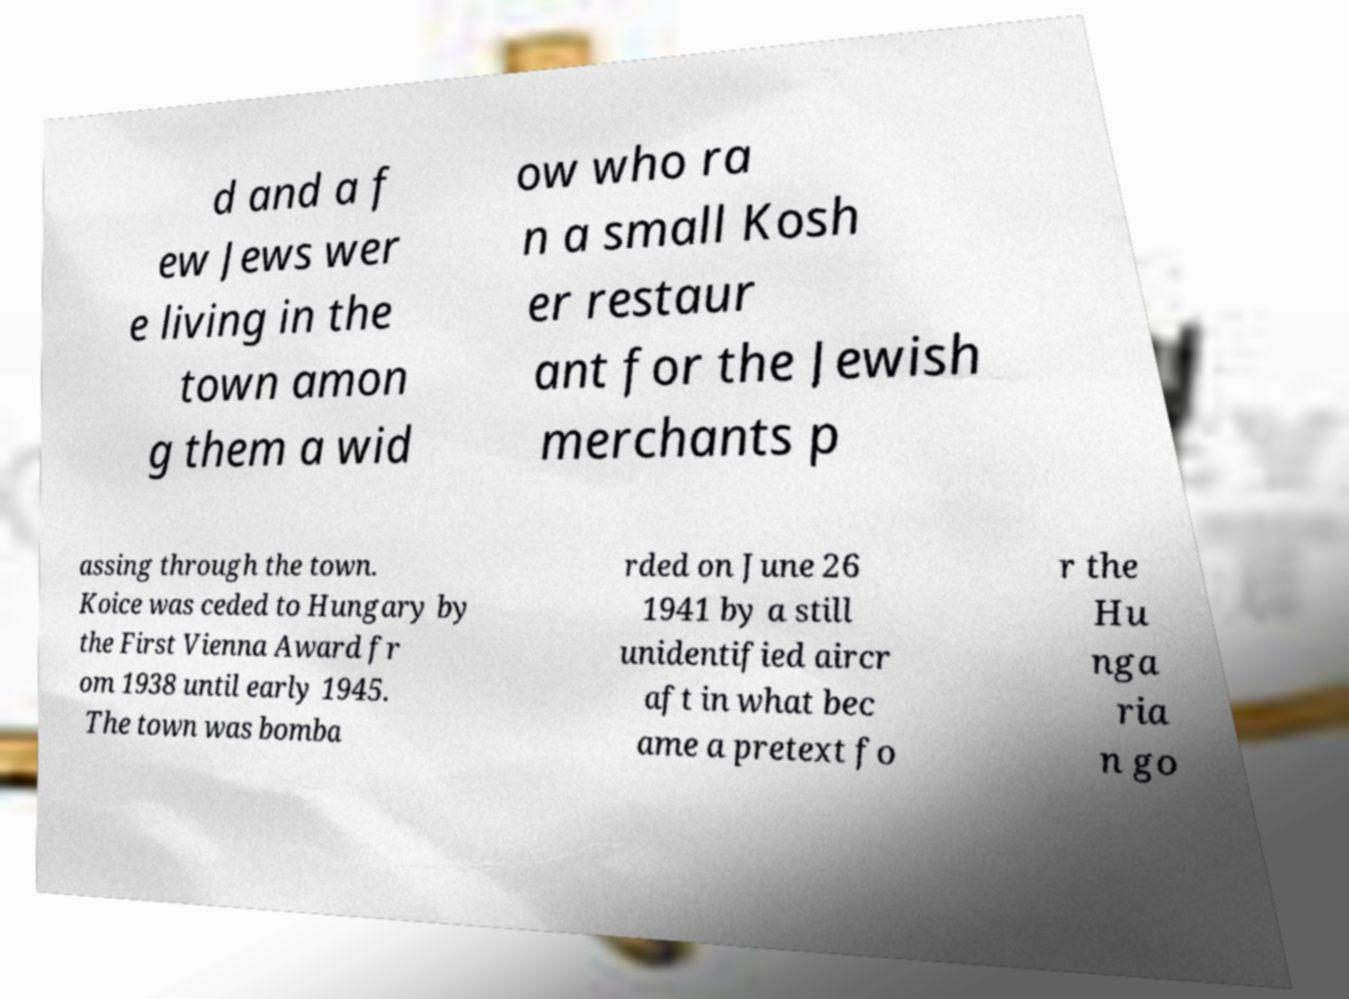What messages or text are displayed in this image? I need them in a readable, typed format. d and a f ew Jews wer e living in the town amon g them a wid ow who ra n a small Kosh er restaur ant for the Jewish merchants p assing through the town. Koice was ceded to Hungary by the First Vienna Award fr om 1938 until early 1945. The town was bomba rded on June 26 1941 by a still unidentified aircr aft in what bec ame a pretext fo r the Hu nga ria n go 